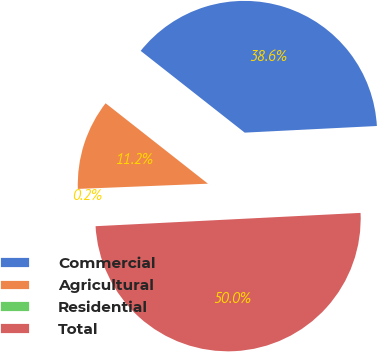Convert chart to OTSL. <chart><loc_0><loc_0><loc_500><loc_500><pie_chart><fcel>Commercial<fcel>Agricultural<fcel>Residential<fcel>Total<nl><fcel>38.6%<fcel>11.24%<fcel>0.16%<fcel>50.0%<nl></chart> 